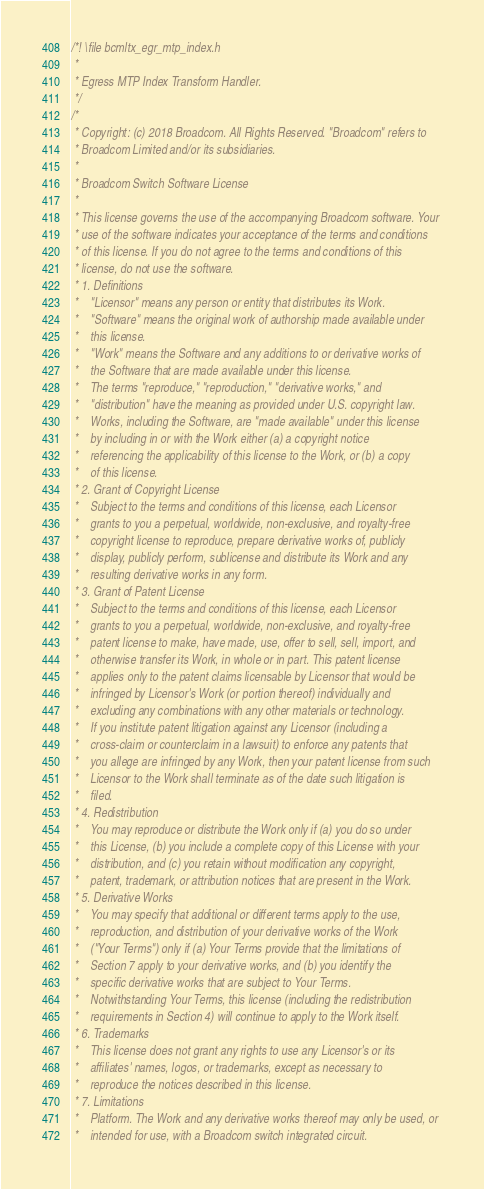<code> <loc_0><loc_0><loc_500><loc_500><_C_>/*! \file bcmltx_egr_mtp_index.h
 *
 * Egress MTP Index Transform Handler.
 */
/*
 * Copyright: (c) 2018 Broadcom. All Rights Reserved. "Broadcom" refers to 
 * Broadcom Limited and/or its subsidiaries.
 * 
 * Broadcom Switch Software License
 * 
 * This license governs the use of the accompanying Broadcom software. Your 
 * use of the software indicates your acceptance of the terms and conditions 
 * of this license. If you do not agree to the terms and conditions of this 
 * license, do not use the software.
 * 1. Definitions
 *    "Licensor" means any person or entity that distributes its Work.
 *    "Software" means the original work of authorship made available under 
 *    this license.
 *    "Work" means the Software and any additions to or derivative works of 
 *    the Software that are made available under this license.
 *    The terms "reproduce," "reproduction," "derivative works," and 
 *    "distribution" have the meaning as provided under U.S. copyright law.
 *    Works, including the Software, are "made available" under this license 
 *    by including in or with the Work either (a) a copyright notice 
 *    referencing the applicability of this license to the Work, or (b) a copy 
 *    of this license.
 * 2. Grant of Copyright License
 *    Subject to the terms and conditions of this license, each Licensor 
 *    grants to you a perpetual, worldwide, non-exclusive, and royalty-free 
 *    copyright license to reproduce, prepare derivative works of, publicly 
 *    display, publicly perform, sublicense and distribute its Work and any 
 *    resulting derivative works in any form.
 * 3. Grant of Patent License
 *    Subject to the terms and conditions of this license, each Licensor 
 *    grants to you a perpetual, worldwide, non-exclusive, and royalty-free 
 *    patent license to make, have made, use, offer to sell, sell, import, and 
 *    otherwise transfer its Work, in whole or in part. This patent license 
 *    applies only to the patent claims licensable by Licensor that would be 
 *    infringed by Licensor's Work (or portion thereof) individually and 
 *    excluding any combinations with any other materials or technology.
 *    If you institute patent litigation against any Licensor (including a 
 *    cross-claim or counterclaim in a lawsuit) to enforce any patents that 
 *    you allege are infringed by any Work, then your patent license from such 
 *    Licensor to the Work shall terminate as of the date such litigation is 
 *    filed.
 * 4. Redistribution
 *    You may reproduce or distribute the Work only if (a) you do so under 
 *    this License, (b) you include a complete copy of this License with your 
 *    distribution, and (c) you retain without modification any copyright, 
 *    patent, trademark, or attribution notices that are present in the Work.
 * 5. Derivative Works
 *    You may specify that additional or different terms apply to the use, 
 *    reproduction, and distribution of your derivative works of the Work 
 *    ("Your Terms") only if (a) Your Terms provide that the limitations of 
 *    Section 7 apply to your derivative works, and (b) you identify the 
 *    specific derivative works that are subject to Your Terms. 
 *    Notwithstanding Your Terms, this license (including the redistribution 
 *    requirements in Section 4) will continue to apply to the Work itself.
 * 6. Trademarks
 *    This license does not grant any rights to use any Licensor's or its 
 *    affiliates' names, logos, or trademarks, except as necessary to 
 *    reproduce the notices described in this license.
 * 7. Limitations
 *    Platform. The Work and any derivative works thereof may only be used, or 
 *    intended for use, with a Broadcom switch integrated circuit.</code> 